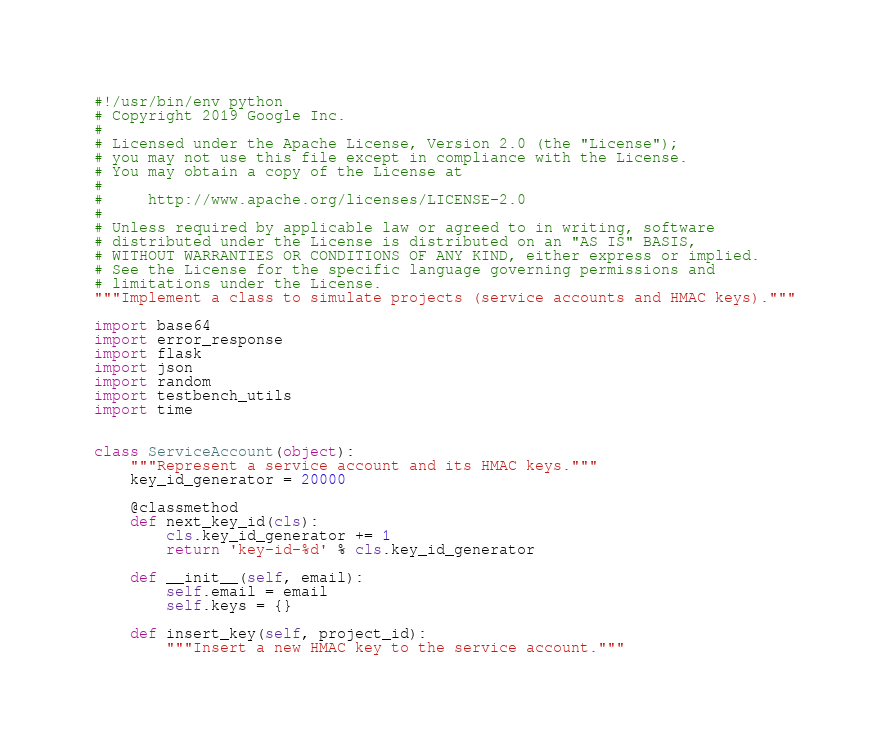<code> <loc_0><loc_0><loc_500><loc_500><_Python_>#!/usr/bin/env python
# Copyright 2019 Google Inc.
#
# Licensed under the Apache License, Version 2.0 (the "License");
# you may not use this file except in compliance with the License.
# You may obtain a copy of the License at
#
#     http://www.apache.org/licenses/LICENSE-2.0
#
# Unless required by applicable law or agreed to in writing, software
# distributed under the License is distributed on an "AS IS" BASIS,
# WITHOUT WARRANTIES OR CONDITIONS OF ANY KIND, either express or implied.
# See the License for the specific language governing permissions and
# limitations under the License.
"""Implement a class to simulate projects (service accounts and HMAC keys)."""

import base64
import error_response
import flask
import json
import random
import testbench_utils
import time


class ServiceAccount(object):
    """Represent a service account and its HMAC keys."""
    key_id_generator = 20000

    @classmethod
    def next_key_id(cls):
        cls.key_id_generator += 1
        return 'key-id-%d' % cls.key_id_generator

    def __init__(self, email):
        self.email = email
        self.keys = {}

    def insert_key(self, project_id):
        """Insert a new HMAC key to the service account."""</code> 